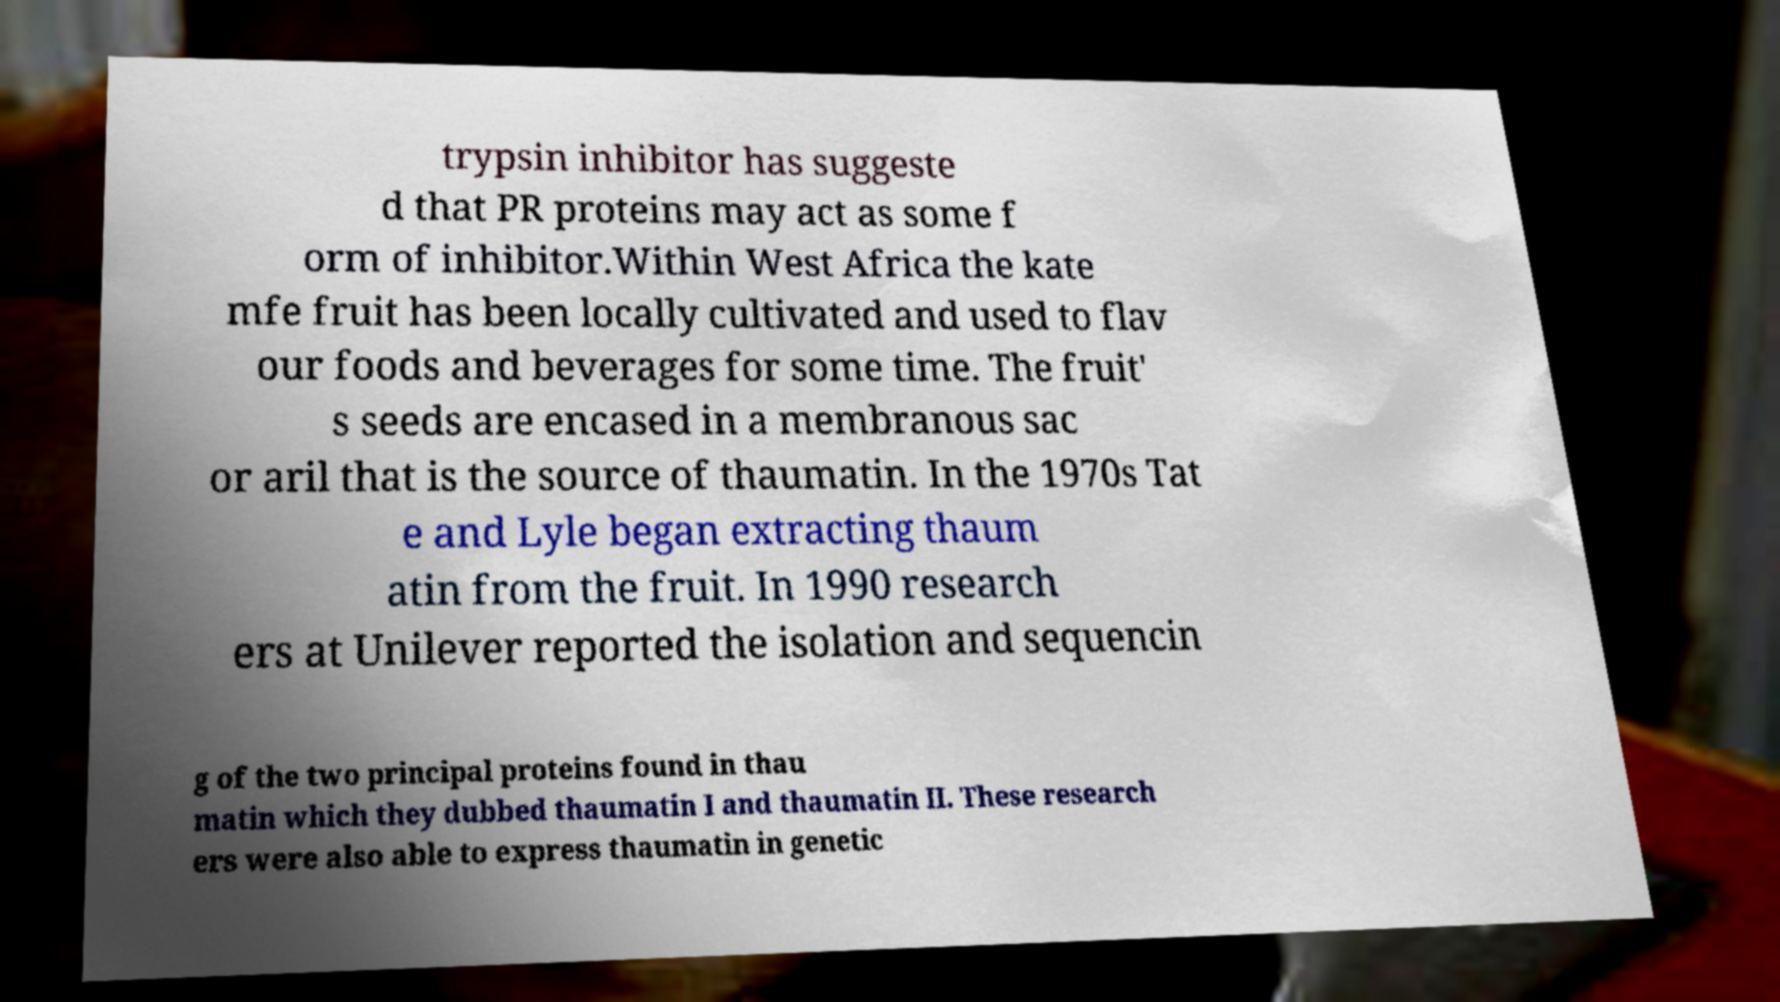What messages or text are displayed in this image? I need them in a readable, typed format. trypsin inhibitor has suggeste d that PR proteins may act as some f orm of inhibitor.Within West Africa the kate mfe fruit has been locally cultivated and used to flav our foods and beverages for some time. The fruit' s seeds are encased in a membranous sac or aril that is the source of thaumatin. In the 1970s Tat e and Lyle began extracting thaum atin from the fruit. In 1990 research ers at Unilever reported the isolation and sequencin g of the two principal proteins found in thau matin which they dubbed thaumatin I and thaumatin II. These research ers were also able to express thaumatin in genetic 